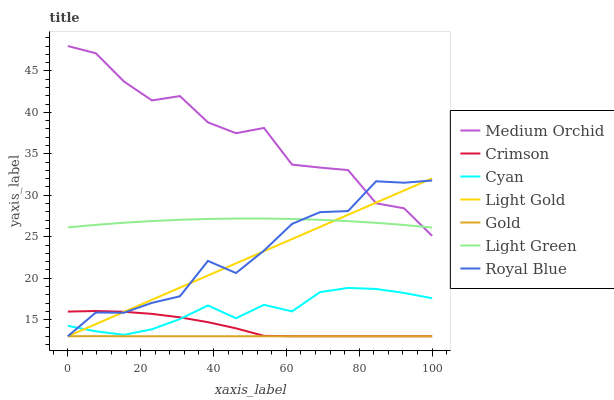Does Gold have the minimum area under the curve?
Answer yes or no. Yes. Does Medium Orchid have the maximum area under the curve?
Answer yes or no. Yes. Does Royal Blue have the minimum area under the curve?
Answer yes or no. No. Does Royal Blue have the maximum area under the curve?
Answer yes or no. No. Is Light Gold the smoothest?
Answer yes or no. Yes. Is Medium Orchid the roughest?
Answer yes or no. Yes. Is Royal Blue the smoothest?
Answer yes or no. No. Is Royal Blue the roughest?
Answer yes or no. No. Does Gold have the lowest value?
Answer yes or no. Yes. Does Medium Orchid have the lowest value?
Answer yes or no. No. Does Medium Orchid have the highest value?
Answer yes or no. Yes. Does Royal Blue have the highest value?
Answer yes or no. No. Is Gold less than Light Green?
Answer yes or no. Yes. Is Light Green greater than Crimson?
Answer yes or no. Yes. Does Gold intersect Crimson?
Answer yes or no. Yes. Is Gold less than Crimson?
Answer yes or no. No. Is Gold greater than Crimson?
Answer yes or no. No. Does Gold intersect Light Green?
Answer yes or no. No. 